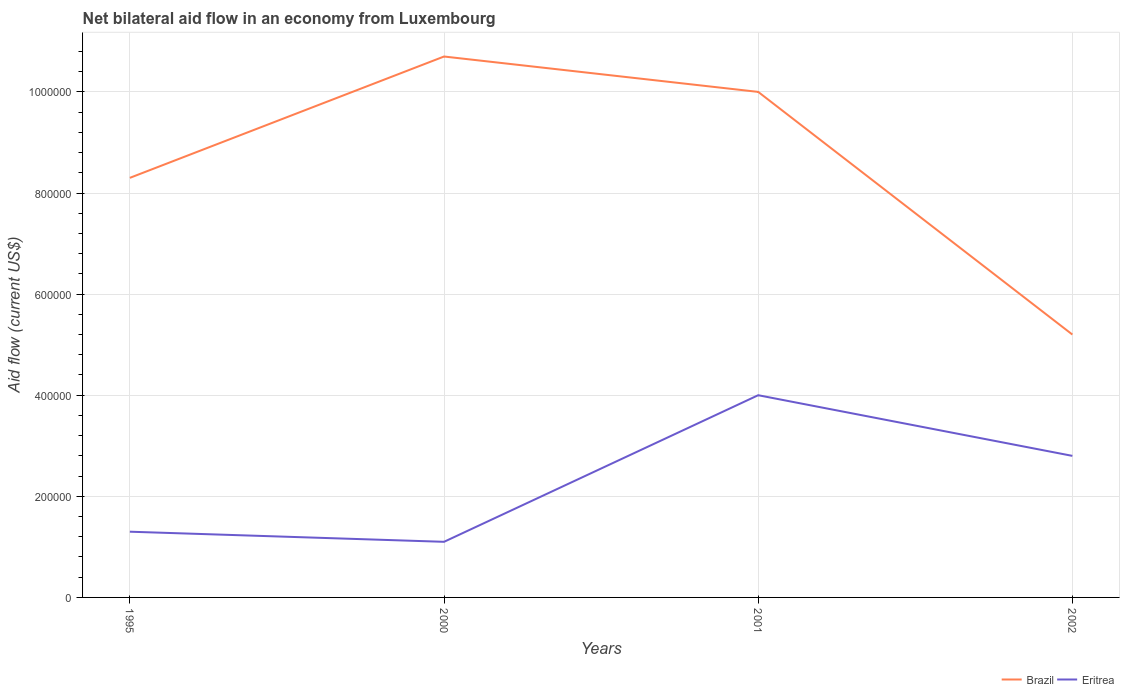How many different coloured lines are there?
Your response must be concise. 2. Does the line corresponding to Eritrea intersect with the line corresponding to Brazil?
Your answer should be compact. No. What is the difference between the highest and the second highest net bilateral aid flow in Brazil?
Give a very brief answer. 5.50e+05. Is the net bilateral aid flow in Eritrea strictly greater than the net bilateral aid flow in Brazil over the years?
Your answer should be compact. Yes. Does the graph contain any zero values?
Provide a succinct answer. No. How many legend labels are there?
Provide a short and direct response. 2. How are the legend labels stacked?
Make the answer very short. Horizontal. What is the title of the graph?
Give a very brief answer. Net bilateral aid flow in an economy from Luxembourg. Does "Dominican Republic" appear as one of the legend labels in the graph?
Offer a terse response. No. What is the label or title of the X-axis?
Make the answer very short. Years. What is the label or title of the Y-axis?
Your response must be concise. Aid flow (current US$). What is the Aid flow (current US$) of Brazil in 1995?
Give a very brief answer. 8.30e+05. What is the Aid flow (current US$) of Eritrea in 1995?
Your response must be concise. 1.30e+05. What is the Aid flow (current US$) in Brazil in 2000?
Make the answer very short. 1.07e+06. What is the Aid flow (current US$) in Brazil in 2001?
Offer a very short reply. 1.00e+06. What is the Aid flow (current US$) of Eritrea in 2001?
Ensure brevity in your answer.  4.00e+05. What is the Aid flow (current US$) of Brazil in 2002?
Offer a very short reply. 5.20e+05. Across all years, what is the maximum Aid flow (current US$) in Brazil?
Offer a very short reply. 1.07e+06. Across all years, what is the maximum Aid flow (current US$) of Eritrea?
Offer a terse response. 4.00e+05. Across all years, what is the minimum Aid flow (current US$) in Brazil?
Make the answer very short. 5.20e+05. What is the total Aid flow (current US$) in Brazil in the graph?
Your response must be concise. 3.42e+06. What is the total Aid flow (current US$) in Eritrea in the graph?
Ensure brevity in your answer.  9.20e+05. What is the difference between the Aid flow (current US$) of Eritrea in 1995 and that in 2000?
Offer a terse response. 2.00e+04. What is the difference between the Aid flow (current US$) of Brazil in 1995 and that in 2002?
Offer a very short reply. 3.10e+05. What is the difference between the Aid flow (current US$) of Eritrea in 1995 and that in 2002?
Offer a very short reply. -1.50e+05. What is the difference between the Aid flow (current US$) of Brazil in 2000 and that in 2001?
Give a very brief answer. 7.00e+04. What is the difference between the Aid flow (current US$) in Eritrea in 2000 and that in 2001?
Your answer should be very brief. -2.90e+05. What is the difference between the Aid flow (current US$) of Eritrea in 2000 and that in 2002?
Offer a terse response. -1.70e+05. What is the difference between the Aid flow (current US$) of Eritrea in 2001 and that in 2002?
Provide a succinct answer. 1.20e+05. What is the difference between the Aid flow (current US$) of Brazil in 1995 and the Aid flow (current US$) of Eritrea in 2000?
Provide a short and direct response. 7.20e+05. What is the difference between the Aid flow (current US$) in Brazil in 1995 and the Aid flow (current US$) in Eritrea in 2002?
Give a very brief answer. 5.50e+05. What is the difference between the Aid flow (current US$) of Brazil in 2000 and the Aid flow (current US$) of Eritrea in 2001?
Your answer should be compact. 6.70e+05. What is the difference between the Aid flow (current US$) of Brazil in 2000 and the Aid flow (current US$) of Eritrea in 2002?
Ensure brevity in your answer.  7.90e+05. What is the difference between the Aid flow (current US$) in Brazil in 2001 and the Aid flow (current US$) in Eritrea in 2002?
Offer a very short reply. 7.20e+05. What is the average Aid flow (current US$) in Brazil per year?
Your answer should be compact. 8.55e+05. In the year 2000, what is the difference between the Aid flow (current US$) in Brazil and Aid flow (current US$) in Eritrea?
Give a very brief answer. 9.60e+05. In the year 2002, what is the difference between the Aid flow (current US$) of Brazil and Aid flow (current US$) of Eritrea?
Keep it short and to the point. 2.40e+05. What is the ratio of the Aid flow (current US$) in Brazil in 1995 to that in 2000?
Offer a very short reply. 0.78. What is the ratio of the Aid flow (current US$) of Eritrea in 1995 to that in 2000?
Make the answer very short. 1.18. What is the ratio of the Aid flow (current US$) of Brazil in 1995 to that in 2001?
Your response must be concise. 0.83. What is the ratio of the Aid flow (current US$) in Eritrea in 1995 to that in 2001?
Provide a succinct answer. 0.33. What is the ratio of the Aid flow (current US$) of Brazil in 1995 to that in 2002?
Ensure brevity in your answer.  1.6. What is the ratio of the Aid flow (current US$) of Eritrea in 1995 to that in 2002?
Ensure brevity in your answer.  0.46. What is the ratio of the Aid flow (current US$) in Brazil in 2000 to that in 2001?
Make the answer very short. 1.07. What is the ratio of the Aid flow (current US$) of Eritrea in 2000 to that in 2001?
Your answer should be compact. 0.28. What is the ratio of the Aid flow (current US$) in Brazil in 2000 to that in 2002?
Your answer should be compact. 2.06. What is the ratio of the Aid flow (current US$) of Eritrea in 2000 to that in 2002?
Offer a very short reply. 0.39. What is the ratio of the Aid flow (current US$) in Brazil in 2001 to that in 2002?
Offer a terse response. 1.92. What is the ratio of the Aid flow (current US$) in Eritrea in 2001 to that in 2002?
Give a very brief answer. 1.43. What is the difference between the highest and the second highest Aid flow (current US$) in Eritrea?
Make the answer very short. 1.20e+05. What is the difference between the highest and the lowest Aid flow (current US$) of Eritrea?
Provide a succinct answer. 2.90e+05. 